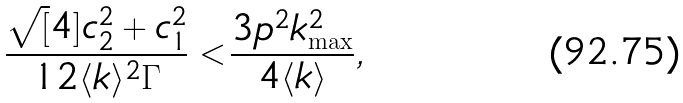<formula> <loc_0><loc_0><loc_500><loc_500>\frac { \sqrt { [ } 4 ] { c _ { 2 } ^ { 2 } + c _ { 1 } ^ { 2 } } } { 1 2 \langle k \rangle ^ { 2 } \Gamma } < \frac { 3 p ^ { 2 } k _ { \max } ^ { 2 } } { 4 \langle k \rangle } ,</formula> 